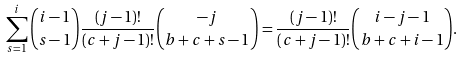Convert formula to latex. <formula><loc_0><loc_0><loc_500><loc_500>\sum _ { s = 1 } ^ { i } \binom { i - 1 } { s - 1 } \frac { ( j - 1 ) ! } { ( c + j - 1 ) ! } \binom { - j } { b + c + s - 1 } = \frac { ( j - 1 ) ! } { ( c + j - 1 ) ! } \binom { i - j - 1 } { b + c + i - 1 } .</formula> 